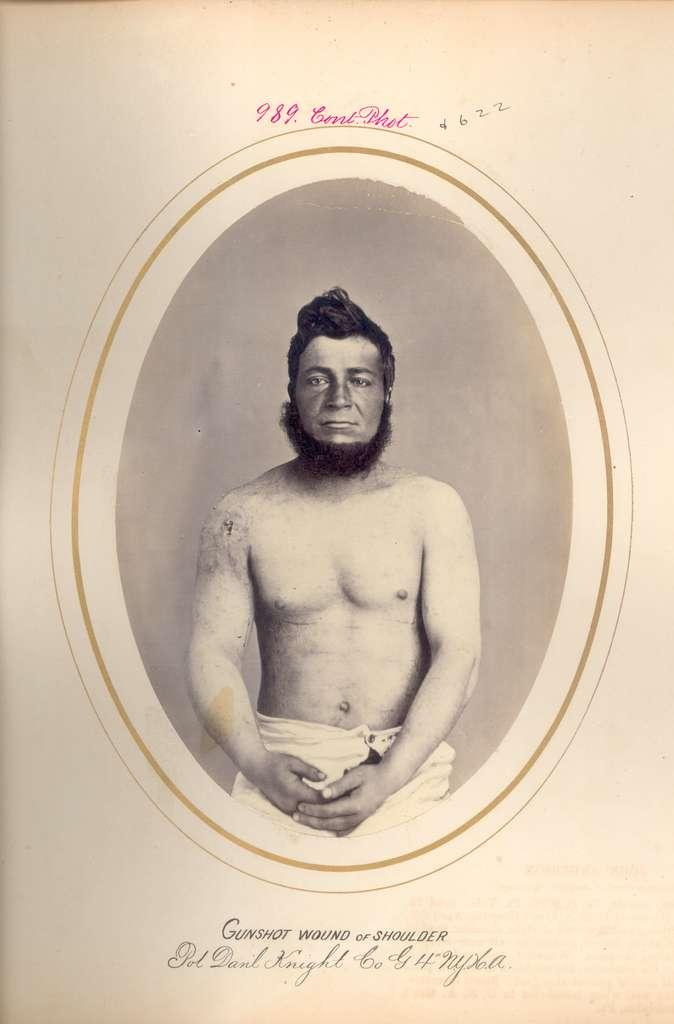What is the main subject of the image? There is a photograph of a man in the image. What type of image is it? The image appears to be a poster. Is there any text in the image? Yes, there is text at the bottom of the image. What type of dock can be seen in the image? There is no dock present in the image; it features a photograph of a man on a poster with text at the bottom. Is the man driving a vehicle in the image? There is no vehicle or driving activity depicted in the image; it only shows a photograph of a man on a poster with text at the bottom. 